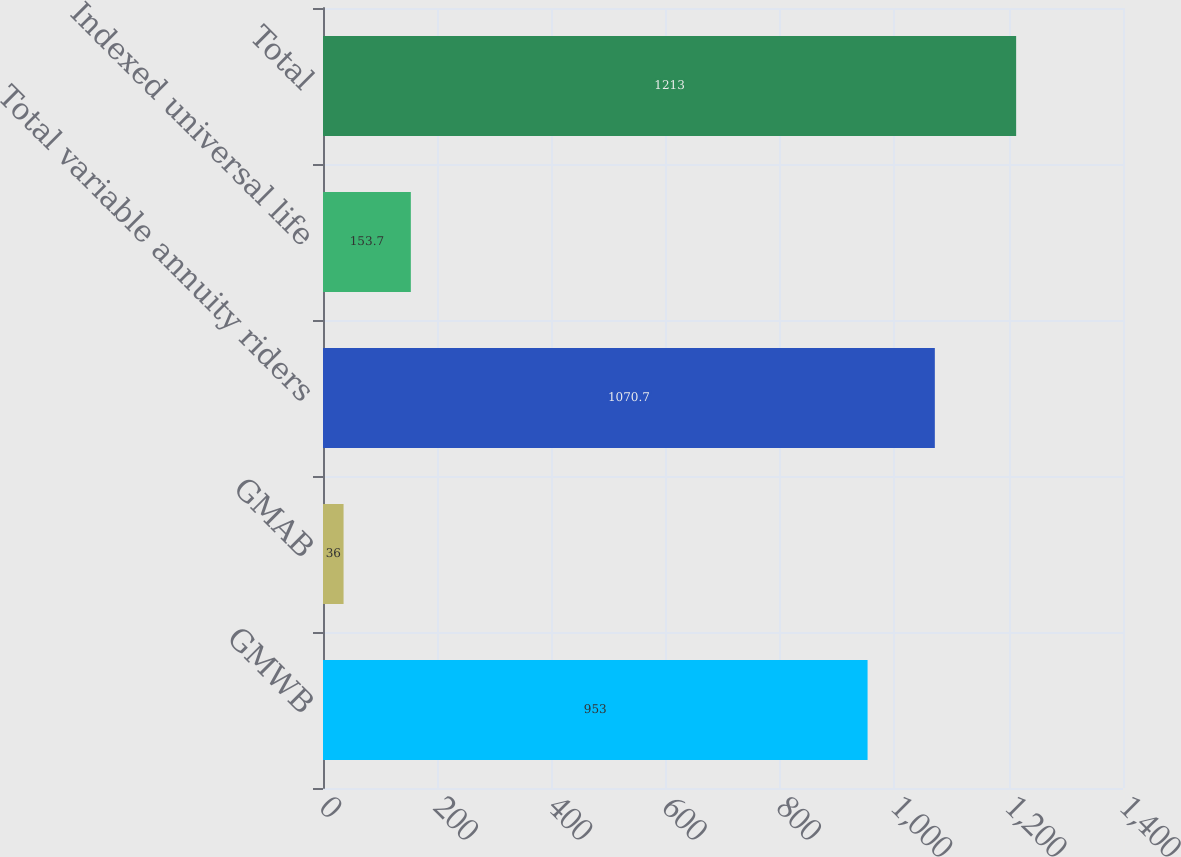Convert chart to OTSL. <chart><loc_0><loc_0><loc_500><loc_500><bar_chart><fcel>GMWB<fcel>GMAB<fcel>Total variable annuity riders<fcel>Indexed universal life<fcel>Total<nl><fcel>953<fcel>36<fcel>1070.7<fcel>153.7<fcel>1213<nl></chart> 